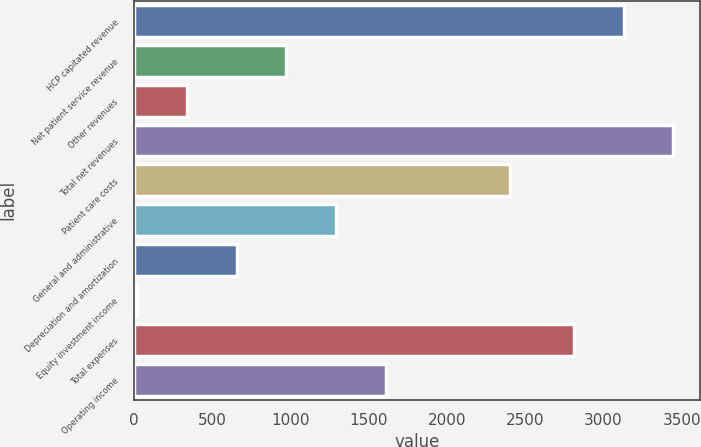<chart> <loc_0><loc_0><loc_500><loc_500><bar_chart><fcel>HCP capitated revenue<fcel>Net patient service revenue<fcel>Other revenues<fcel>Total net revenues<fcel>Patient care costs<fcel>General and administrative<fcel>Depreciation and amortization<fcel>Equity investment income<fcel>Total expenses<fcel>Operating income<nl><fcel>3128.3<fcel>974.9<fcel>340.3<fcel>3445.6<fcel>2405<fcel>1292.2<fcel>657.6<fcel>23<fcel>2811<fcel>1609.5<nl></chart> 